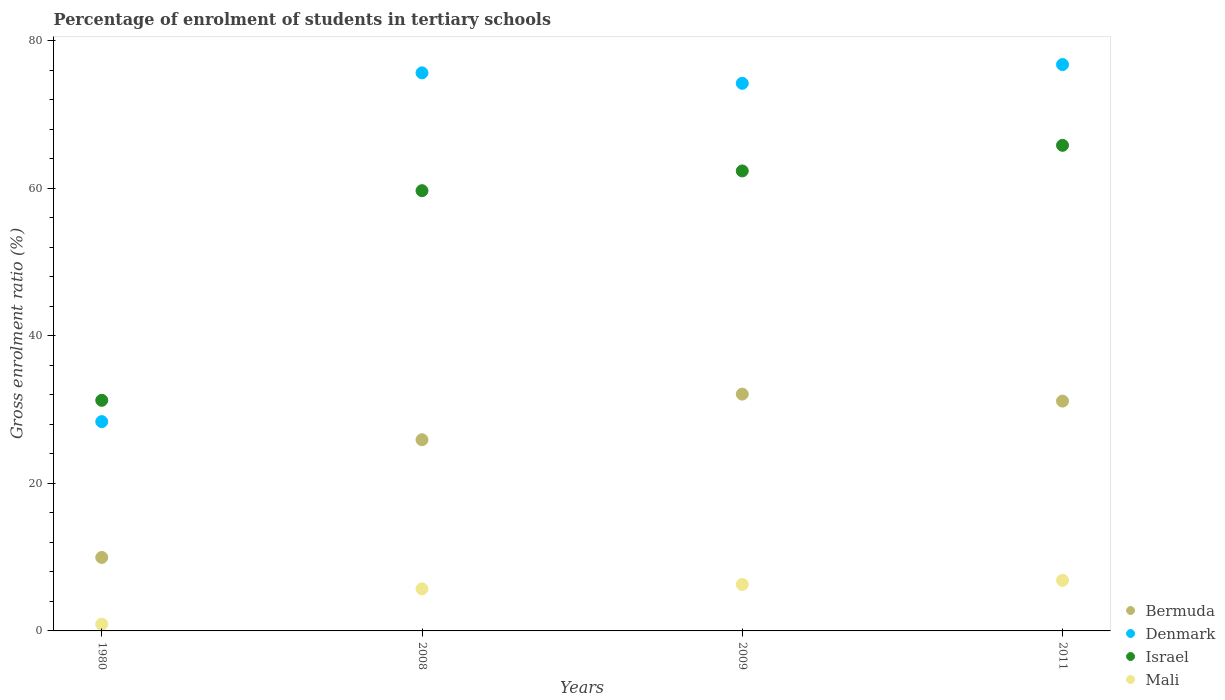What is the percentage of students enrolled in tertiary schools in Mali in 2008?
Give a very brief answer. 5.7. Across all years, what is the maximum percentage of students enrolled in tertiary schools in Israel?
Provide a short and direct response. 65.85. Across all years, what is the minimum percentage of students enrolled in tertiary schools in Mali?
Your answer should be compact. 0.91. In which year was the percentage of students enrolled in tertiary schools in Denmark maximum?
Ensure brevity in your answer.  2011. What is the total percentage of students enrolled in tertiary schools in Denmark in the graph?
Offer a very short reply. 255.11. What is the difference between the percentage of students enrolled in tertiary schools in Mali in 1980 and that in 2009?
Ensure brevity in your answer.  -5.39. What is the difference between the percentage of students enrolled in tertiary schools in Mali in 1980 and the percentage of students enrolled in tertiary schools in Israel in 2009?
Ensure brevity in your answer.  -61.46. What is the average percentage of students enrolled in tertiary schools in Israel per year?
Offer a very short reply. 54.8. In the year 1980, what is the difference between the percentage of students enrolled in tertiary schools in Bermuda and percentage of students enrolled in tertiary schools in Israel?
Keep it short and to the point. -21.31. What is the ratio of the percentage of students enrolled in tertiary schools in Mali in 2008 to that in 2009?
Your answer should be compact. 0.91. What is the difference between the highest and the second highest percentage of students enrolled in tertiary schools in Mali?
Your answer should be very brief. 0.56. What is the difference between the highest and the lowest percentage of students enrolled in tertiary schools in Bermuda?
Ensure brevity in your answer.  22.15. In how many years, is the percentage of students enrolled in tertiary schools in Bermuda greater than the average percentage of students enrolled in tertiary schools in Bermuda taken over all years?
Ensure brevity in your answer.  3. Is the sum of the percentage of students enrolled in tertiary schools in Bermuda in 2008 and 2011 greater than the maximum percentage of students enrolled in tertiary schools in Denmark across all years?
Offer a terse response. No. Is it the case that in every year, the sum of the percentage of students enrolled in tertiary schools in Mali and percentage of students enrolled in tertiary schools in Denmark  is greater than the percentage of students enrolled in tertiary schools in Israel?
Your response must be concise. No. Does the percentage of students enrolled in tertiary schools in Bermuda monotonically increase over the years?
Your response must be concise. No. Is the percentage of students enrolled in tertiary schools in Israel strictly less than the percentage of students enrolled in tertiary schools in Mali over the years?
Give a very brief answer. No. What is the difference between two consecutive major ticks on the Y-axis?
Give a very brief answer. 20. Are the values on the major ticks of Y-axis written in scientific E-notation?
Give a very brief answer. No. Does the graph contain any zero values?
Offer a terse response. No. Does the graph contain grids?
Provide a short and direct response. No. How many legend labels are there?
Your answer should be compact. 4. How are the legend labels stacked?
Give a very brief answer. Vertical. What is the title of the graph?
Your response must be concise. Percentage of enrolment of students in tertiary schools. Does "Togo" appear as one of the legend labels in the graph?
Offer a terse response. No. What is the label or title of the X-axis?
Provide a succinct answer. Years. What is the Gross enrolment ratio (%) of Bermuda in 1980?
Offer a terse response. 9.96. What is the Gross enrolment ratio (%) of Denmark in 1980?
Give a very brief answer. 28.38. What is the Gross enrolment ratio (%) of Israel in 1980?
Offer a terse response. 31.27. What is the Gross enrolment ratio (%) of Mali in 1980?
Offer a terse response. 0.91. What is the Gross enrolment ratio (%) in Bermuda in 2008?
Give a very brief answer. 25.93. What is the Gross enrolment ratio (%) in Denmark in 2008?
Offer a terse response. 75.68. What is the Gross enrolment ratio (%) of Israel in 2008?
Keep it short and to the point. 59.7. What is the Gross enrolment ratio (%) in Mali in 2008?
Your response must be concise. 5.7. What is the Gross enrolment ratio (%) in Bermuda in 2009?
Give a very brief answer. 32.11. What is the Gross enrolment ratio (%) of Denmark in 2009?
Your response must be concise. 74.26. What is the Gross enrolment ratio (%) of Israel in 2009?
Keep it short and to the point. 62.38. What is the Gross enrolment ratio (%) of Mali in 2009?
Keep it short and to the point. 6.3. What is the Gross enrolment ratio (%) of Bermuda in 2011?
Your answer should be very brief. 31.17. What is the Gross enrolment ratio (%) of Denmark in 2011?
Ensure brevity in your answer.  76.8. What is the Gross enrolment ratio (%) in Israel in 2011?
Provide a short and direct response. 65.85. What is the Gross enrolment ratio (%) of Mali in 2011?
Provide a short and direct response. 6.86. Across all years, what is the maximum Gross enrolment ratio (%) of Bermuda?
Give a very brief answer. 32.11. Across all years, what is the maximum Gross enrolment ratio (%) in Denmark?
Your answer should be compact. 76.8. Across all years, what is the maximum Gross enrolment ratio (%) of Israel?
Your answer should be compact. 65.85. Across all years, what is the maximum Gross enrolment ratio (%) in Mali?
Provide a short and direct response. 6.86. Across all years, what is the minimum Gross enrolment ratio (%) of Bermuda?
Provide a succinct answer. 9.96. Across all years, what is the minimum Gross enrolment ratio (%) in Denmark?
Make the answer very short. 28.38. Across all years, what is the minimum Gross enrolment ratio (%) of Israel?
Keep it short and to the point. 31.27. Across all years, what is the minimum Gross enrolment ratio (%) in Mali?
Provide a short and direct response. 0.91. What is the total Gross enrolment ratio (%) in Bermuda in the graph?
Keep it short and to the point. 99.17. What is the total Gross enrolment ratio (%) in Denmark in the graph?
Offer a very short reply. 255.11. What is the total Gross enrolment ratio (%) of Israel in the graph?
Provide a short and direct response. 219.19. What is the total Gross enrolment ratio (%) in Mali in the graph?
Offer a very short reply. 19.77. What is the difference between the Gross enrolment ratio (%) of Bermuda in 1980 and that in 2008?
Offer a very short reply. -15.96. What is the difference between the Gross enrolment ratio (%) of Denmark in 1980 and that in 2008?
Ensure brevity in your answer.  -47.29. What is the difference between the Gross enrolment ratio (%) in Israel in 1980 and that in 2008?
Offer a very short reply. -28.43. What is the difference between the Gross enrolment ratio (%) of Mali in 1980 and that in 2008?
Offer a very short reply. -4.79. What is the difference between the Gross enrolment ratio (%) in Bermuda in 1980 and that in 2009?
Keep it short and to the point. -22.15. What is the difference between the Gross enrolment ratio (%) in Denmark in 1980 and that in 2009?
Your answer should be compact. -45.88. What is the difference between the Gross enrolment ratio (%) in Israel in 1980 and that in 2009?
Your response must be concise. -31.1. What is the difference between the Gross enrolment ratio (%) in Mali in 1980 and that in 2009?
Ensure brevity in your answer.  -5.39. What is the difference between the Gross enrolment ratio (%) in Bermuda in 1980 and that in 2011?
Your answer should be very brief. -21.2. What is the difference between the Gross enrolment ratio (%) in Denmark in 1980 and that in 2011?
Offer a terse response. -48.42. What is the difference between the Gross enrolment ratio (%) of Israel in 1980 and that in 2011?
Give a very brief answer. -34.58. What is the difference between the Gross enrolment ratio (%) of Mali in 1980 and that in 2011?
Make the answer very short. -5.95. What is the difference between the Gross enrolment ratio (%) of Bermuda in 2008 and that in 2009?
Your answer should be compact. -6.18. What is the difference between the Gross enrolment ratio (%) in Denmark in 2008 and that in 2009?
Your answer should be compact. 1.42. What is the difference between the Gross enrolment ratio (%) of Israel in 2008 and that in 2009?
Provide a short and direct response. -2.68. What is the difference between the Gross enrolment ratio (%) in Mali in 2008 and that in 2009?
Give a very brief answer. -0.6. What is the difference between the Gross enrolment ratio (%) of Bermuda in 2008 and that in 2011?
Offer a terse response. -5.24. What is the difference between the Gross enrolment ratio (%) of Denmark in 2008 and that in 2011?
Provide a succinct answer. -1.13. What is the difference between the Gross enrolment ratio (%) of Israel in 2008 and that in 2011?
Keep it short and to the point. -6.15. What is the difference between the Gross enrolment ratio (%) in Mali in 2008 and that in 2011?
Provide a succinct answer. -1.16. What is the difference between the Gross enrolment ratio (%) in Bermuda in 2009 and that in 2011?
Ensure brevity in your answer.  0.95. What is the difference between the Gross enrolment ratio (%) in Denmark in 2009 and that in 2011?
Offer a very short reply. -2.54. What is the difference between the Gross enrolment ratio (%) in Israel in 2009 and that in 2011?
Offer a terse response. -3.47. What is the difference between the Gross enrolment ratio (%) in Mali in 2009 and that in 2011?
Your answer should be compact. -0.56. What is the difference between the Gross enrolment ratio (%) in Bermuda in 1980 and the Gross enrolment ratio (%) in Denmark in 2008?
Your answer should be very brief. -65.71. What is the difference between the Gross enrolment ratio (%) in Bermuda in 1980 and the Gross enrolment ratio (%) in Israel in 2008?
Ensure brevity in your answer.  -49.73. What is the difference between the Gross enrolment ratio (%) of Bermuda in 1980 and the Gross enrolment ratio (%) of Mali in 2008?
Give a very brief answer. 4.26. What is the difference between the Gross enrolment ratio (%) of Denmark in 1980 and the Gross enrolment ratio (%) of Israel in 2008?
Ensure brevity in your answer.  -31.32. What is the difference between the Gross enrolment ratio (%) of Denmark in 1980 and the Gross enrolment ratio (%) of Mali in 2008?
Make the answer very short. 22.68. What is the difference between the Gross enrolment ratio (%) in Israel in 1980 and the Gross enrolment ratio (%) in Mali in 2008?
Give a very brief answer. 25.57. What is the difference between the Gross enrolment ratio (%) of Bermuda in 1980 and the Gross enrolment ratio (%) of Denmark in 2009?
Ensure brevity in your answer.  -64.29. What is the difference between the Gross enrolment ratio (%) of Bermuda in 1980 and the Gross enrolment ratio (%) of Israel in 2009?
Ensure brevity in your answer.  -52.41. What is the difference between the Gross enrolment ratio (%) of Bermuda in 1980 and the Gross enrolment ratio (%) of Mali in 2009?
Give a very brief answer. 3.66. What is the difference between the Gross enrolment ratio (%) of Denmark in 1980 and the Gross enrolment ratio (%) of Israel in 2009?
Provide a short and direct response. -33.99. What is the difference between the Gross enrolment ratio (%) in Denmark in 1980 and the Gross enrolment ratio (%) in Mali in 2009?
Offer a terse response. 22.08. What is the difference between the Gross enrolment ratio (%) in Israel in 1980 and the Gross enrolment ratio (%) in Mali in 2009?
Your answer should be compact. 24.97. What is the difference between the Gross enrolment ratio (%) of Bermuda in 1980 and the Gross enrolment ratio (%) of Denmark in 2011?
Offer a terse response. -66.84. What is the difference between the Gross enrolment ratio (%) of Bermuda in 1980 and the Gross enrolment ratio (%) of Israel in 2011?
Provide a succinct answer. -55.88. What is the difference between the Gross enrolment ratio (%) of Bermuda in 1980 and the Gross enrolment ratio (%) of Mali in 2011?
Your answer should be very brief. 3.1. What is the difference between the Gross enrolment ratio (%) in Denmark in 1980 and the Gross enrolment ratio (%) in Israel in 2011?
Provide a succinct answer. -37.47. What is the difference between the Gross enrolment ratio (%) of Denmark in 1980 and the Gross enrolment ratio (%) of Mali in 2011?
Ensure brevity in your answer.  21.52. What is the difference between the Gross enrolment ratio (%) of Israel in 1980 and the Gross enrolment ratio (%) of Mali in 2011?
Give a very brief answer. 24.41. What is the difference between the Gross enrolment ratio (%) of Bermuda in 2008 and the Gross enrolment ratio (%) of Denmark in 2009?
Ensure brevity in your answer.  -48.33. What is the difference between the Gross enrolment ratio (%) of Bermuda in 2008 and the Gross enrolment ratio (%) of Israel in 2009?
Your response must be concise. -36.45. What is the difference between the Gross enrolment ratio (%) in Bermuda in 2008 and the Gross enrolment ratio (%) in Mali in 2009?
Give a very brief answer. 19.63. What is the difference between the Gross enrolment ratio (%) of Denmark in 2008 and the Gross enrolment ratio (%) of Israel in 2009?
Offer a terse response. 13.3. What is the difference between the Gross enrolment ratio (%) of Denmark in 2008 and the Gross enrolment ratio (%) of Mali in 2009?
Ensure brevity in your answer.  69.38. What is the difference between the Gross enrolment ratio (%) in Israel in 2008 and the Gross enrolment ratio (%) in Mali in 2009?
Offer a terse response. 53.4. What is the difference between the Gross enrolment ratio (%) in Bermuda in 2008 and the Gross enrolment ratio (%) in Denmark in 2011?
Give a very brief answer. -50.88. What is the difference between the Gross enrolment ratio (%) in Bermuda in 2008 and the Gross enrolment ratio (%) in Israel in 2011?
Offer a terse response. -39.92. What is the difference between the Gross enrolment ratio (%) in Bermuda in 2008 and the Gross enrolment ratio (%) in Mali in 2011?
Your response must be concise. 19.07. What is the difference between the Gross enrolment ratio (%) of Denmark in 2008 and the Gross enrolment ratio (%) of Israel in 2011?
Your answer should be very brief. 9.83. What is the difference between the Gross enrolment ratio (%) of Denmark in 2008 and the Gross enrolment ratio (%) of Mali in 2011?
Your answer should be compact. 68.82. What is the difference between the Gross enrolment ratio (%) in Israel in 2008 and the Gross enrolment ratio (%) in Mali in 2011?
Your response must be concise. 52.84. What is the difference between the Gross enrolment ratio (%) of Bermuda in 2009 and the Gross enrolment ratio (%) of Denmark in 2011?
Keep it short and to the point. -44.69. What is the difference between the Gross enrolment ratio (%) of Bermuda in 2009 and the Gross enrolment ratio (%) of Israel in 2011?
Provide a short and direct response. -33.74. What is the difference between the Gross enrolment ratio (%) in Bermuda in 2009 and the Gross enrolment ratio (%) in Mali in 2011?
Your answer should be very brief. 25.25. What is the difference between the Gross enrolment ratio (%) in Denmark in 2009 and the Gross enrolment ratio (%) in Israel in 2011?
Keep it short and to the point. 8.41. What is the difference between the Gross enrolment ratio (%) in Denmark in 2009 and the Gross enrolment ratio (%) in Mali in 2011?
Ensure brevity in your answer.  67.4. What is the difference between the Gross enrolment ratio (%) in Israel in 2009 and the Gross enrolment ratio (%) in Mali in 2011?
Make the answer very short. 55.52. What is the average Gross enrolment ratio (%) in Bermuda per year?
Give a very brief answer. 24.79. What is the average Gross enrolment ratio (%) of Denmark per year?
Keep it short and to the point. 63.78. What is the average Gross enrolment ratio (%) in Israel per year?
Provide a succinct answer. 54.8. What is the average Gross enrolment ratio (%) of Mali per year?
Make the answer very short. 4.94. In the year 1980, what is the difference between the Gross enrolment ratio (%) in Bermuda and Gross enrolment ratio (%) in Denmark?
Make the answer very short. -18.42. In the year 1980, what is the difference between the Gross enrolment ratio (%) of Bermuda and Gross enrolment ratio (%) of Israel?
Keep it short and to the point. -21.31. In the year 1980, what is the difference between the Gross enrolment ratio (%) in Bermuda and Gross enrolment ratio (%) in Mali?
Keep it short and to the point. 9.05. In the year 1980, what is the difference between the Gross enrolment ratio (%) of Denmark and Gross enrolment ratio (%) of Israel?
Keep it short and to the point. -2.89. In the year 1980, what is the difference between the Gross enrolment ratio (%) of Denmark and Gross enrolment ratio (%) of Mali?
Offer a terse response. 27.47. In the year 1980, what is the difference between the Gross enrolment ratio (%) of Israel and Gross enrolment ratio (%) of Mali?
Ensure brevity in your answer.  30.36. In the year 2008, what is the difference between the Gross enrolment ratio (%) of Bermuda and Gross enrolment ratio (%) of Denmark?
Ensure brevity in your answer.  -49.75. In the year 2008, what is the difference between the Gross enrolment ratio (%) of Bermuda and Gross enrolment ratio (%) of Israel?
Make the answer very short. -33.77. In the year 2008, what is the difference between the Gross enrolment ratio (%) in Bermuda and Gross enrolment ratio (%) in Mali?
Your response must be concise. 20.22. In the year 2008, what is the difference between the Gross enrolment ratio (%) in Denmark and Gross enrolment ratio (%) in Israel?
Your response must be concise. 15.98. In the year 2008, what is the difference between the Gross enrolment ratio (%) of Denmark and Gross enrolment ratio (%) of Mali?
Ensure brevity in your answer.  69.97. In the year 2008, what is the difference between the Gross enrolment ratio (%) in Israel and Gross enrolment ratio (%) in Mali?
Your response must be concise. 53.99. In the year 2009, what is the difference between the Gross enrolment ratio (%) of Bermuda and Gross enrolment ratio (%) of Denmark?
Provide a succinct answer. -42.15. In the year 2009, what is the difference between the Gross enrolment ratio (%) in Bermuda and Gross enrolment ratio (%) in Israel?
Provide a succinct answer. -30.26. In the year 2009, what is the difference between the Gross enrolment ratio (%) in Bermuda and Gross enrolment ratio (%) in Mali?
Keep it short and to the point. 25.81. In the year 2009, what is the difference between the Gross enrolment ratio (%) in Denmark and Gross enrolment ratio (%) in Israel?
Give a very brief answer. 11.88. In the year 2009, what is the difference between the Gross enrolment ratio (%) of Denmark and Gross enrolment ratio (%) of Mali?
Your response must be concise. 67.96. In the year 2009, what is the difference between the Gross enrolment ratio (%) in Israel and Gross enrolment ratio (%) in Mali?
Provide a short and direct response. 56.08. In the year 2011, what is the difference between the Gross enrolment ratio (%) in Bermuda and Gross enrolment ratio (%) in Denmark?
Offer a terse response. -45.64. In the year 2011, what is the difference between the Gross enrolment ratio (%) of Bermuda and Gross enrolment ratio (%) of Israel?
Keep it short and to the point. -34.68. In the year 2011, what is the difference between the Gross enrolment ratio (%) in Bermuda and Gross enrolment ratio (%) in Mali?
Offer a very short reply. 24.31. In the year 2011, what is the difference between the Gross enrolment ratio (%) in Denmark and Gross enrolment ratio (%) in Israel?
Provide a succinct answer. 10.95. In the year 2011, what is the difference between the Gross enrolment ratio (%) in Denmark and Gross enrolment ratio (%) in Mali?
Ensure brevity in your answer.  69.94. In the year 2011, what is the difference between the Gross enrolment ratio (%) in Israel and Gross enrolment ratio (%) in Mali?
Your answer should be very brief. 58.99. What is the ratio of the Gross enrolment ratio (%) of Bermuda in 1980 to that in 2008?
Your answer should be compact. 0.38. What is the ratio of the Gross enrolment ratio (%) in Israel in 1980 to that in 2008?
Your response must be concise. 0.52. What is the ratio of the Gross enrolment ratio (%) of Mali in 1980 to that in 2008?
Offer a terse response. 0.16. What is the ratio of the Gross enrolment ratio (%) in Bermuda in 1980 to that in 2009?
Keep it short and to the point. 0.31. What is the ratio of the Gross enrolment ratio (%) of Denmark in 1980 to that in 2009?
Provide a short and direct response. 0.38. What is the ratio of the Gross enrolment ratio (%) of Israel in 1980 to that in 2009?
Your answer should be compact. 0.5. What is the ratio of the Gross enrolment ratio (%) in Mali in 1980 to that in 2009?
Make the answer very short. 0.14. What is the ratio of the Gross enrolment ratio (%) in Bermuda in 1980 to that in 2011?
Provide a succinct answer. 0.32. What is the ratio of the Gross enrolment ratio (%) of Denmark in 1980 to that in 2011?
Make the answer very short. 0.37. What is the ratio of the Gross enrolment ratio (%) in Israel in 1980 to that in 2011?
Ensure brevity in your answer.  0.47. What is the ratio of the Gross enrolment ratio (%) in Mali in 1980 to that in 2011?
Provide a short and direct response. 0.13. What is the ratio of the Gross enrolment ratio (%) in Bermuda in 2008 to that in 2009?
Keep it short and to the point. 0.81. What is the ratio of the Gross enrolment ratio (%) in Denmark in 2008 to that in 2009?
Your answer should be very brief. 1.02. What is the ratio of the Gross enrolment ratio (%) in Israel in 2008 to that in 2009?
Make the answer very short. 0.96. What is the ratio of the Gross enrolment ratio (%) in Mali in 2008 to that in 2009?
Keep it short and to the point. 0.91. What is the ratio of the Gross enrolment ratio (%) of Bermuda in 2008 to that in 2011?
Your answer should be very brief. 0.83. What is the ratio of the Gross enrolment ratio (%) of Denmark in 2008 to that in 2011?
Give a very brief answer. 0.99. What is the ratio of the Gross enrolment ratio (%) of Israel in 2008 to that in 2011?
Provide a short and direct response. 0.91. What is the ratio of the Gross enrolment ratio (%) in Mali in 2008 to that in 2011?
Your response must be concise. 0.83. What is the ratio of the Gross enrolment ratio (%) in Bermuda in 2009 to that in 2011?
Offer a very short reply. 1.03. What is the ratio of the Gross enrolment ratio (%) of Denmark in 2009 to that in 2011?
Your answer should be very brief. 0.97. What is the ratio of the Gross enrolment ratio (%) in Israel in 2009 to that in 2011?
Offer a terse response. 0.95. What is the ratio of the Gross enrolment ratio (%) of Mali in 2009 to that in 2011?
Your response must be concise. 0.92. What is the difference between the highest and the second highest Gross enrolment ratio (%) in Bermuda?
Your answer should be very brief. 0.95. What is the difference between the highest and the second highest Gross enrolment ratio (%) in Denmark?
Provide a succinct answer. 1.13. What is the difference between the highest and the second highest Gross enrolment ratio (%) of Israel?
Your response must be concise. 3.47. What is the difference between the highest and the second highest Gross enrolment ratio (%) in Mali?
Offer a terse response. 0.56. What is the difference between the highest and the lowest Gross enrolment ratio (%) of Bermuda?
Make the answer very short. 22.15. What is the difference between the highest and the lowest Gross enrolment ratio (%) in Denmark?
Offer a very short reply. 48.42. What is the difference between the highest and the lowest Gross enrolment ratio (%) of Israel?
Provide a succinct answer. 34.58. What is the difference between the highest and the lowest Gross enrolment ratio (%) of Mali?
Make the answer very short. 5.95. 